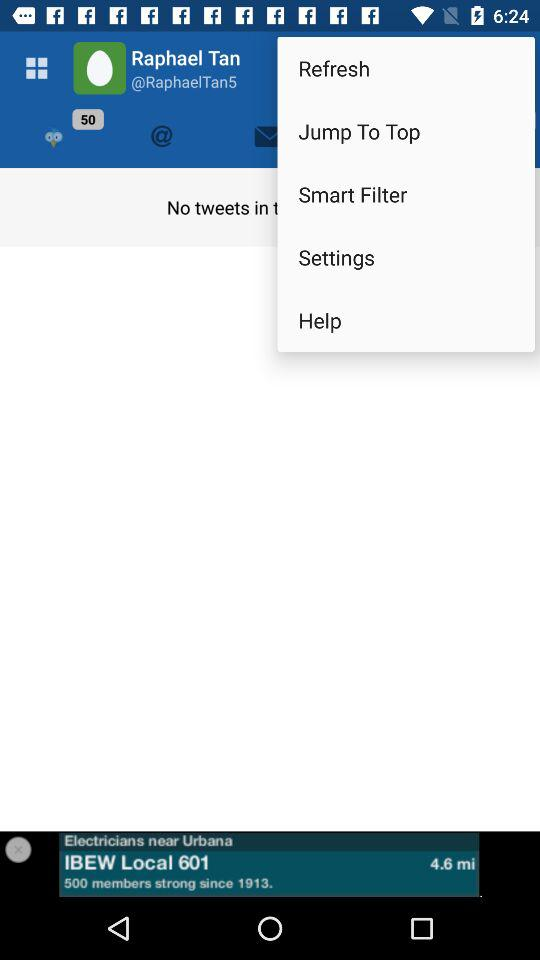How many notifications are pending? There are 50 notifications pending. 